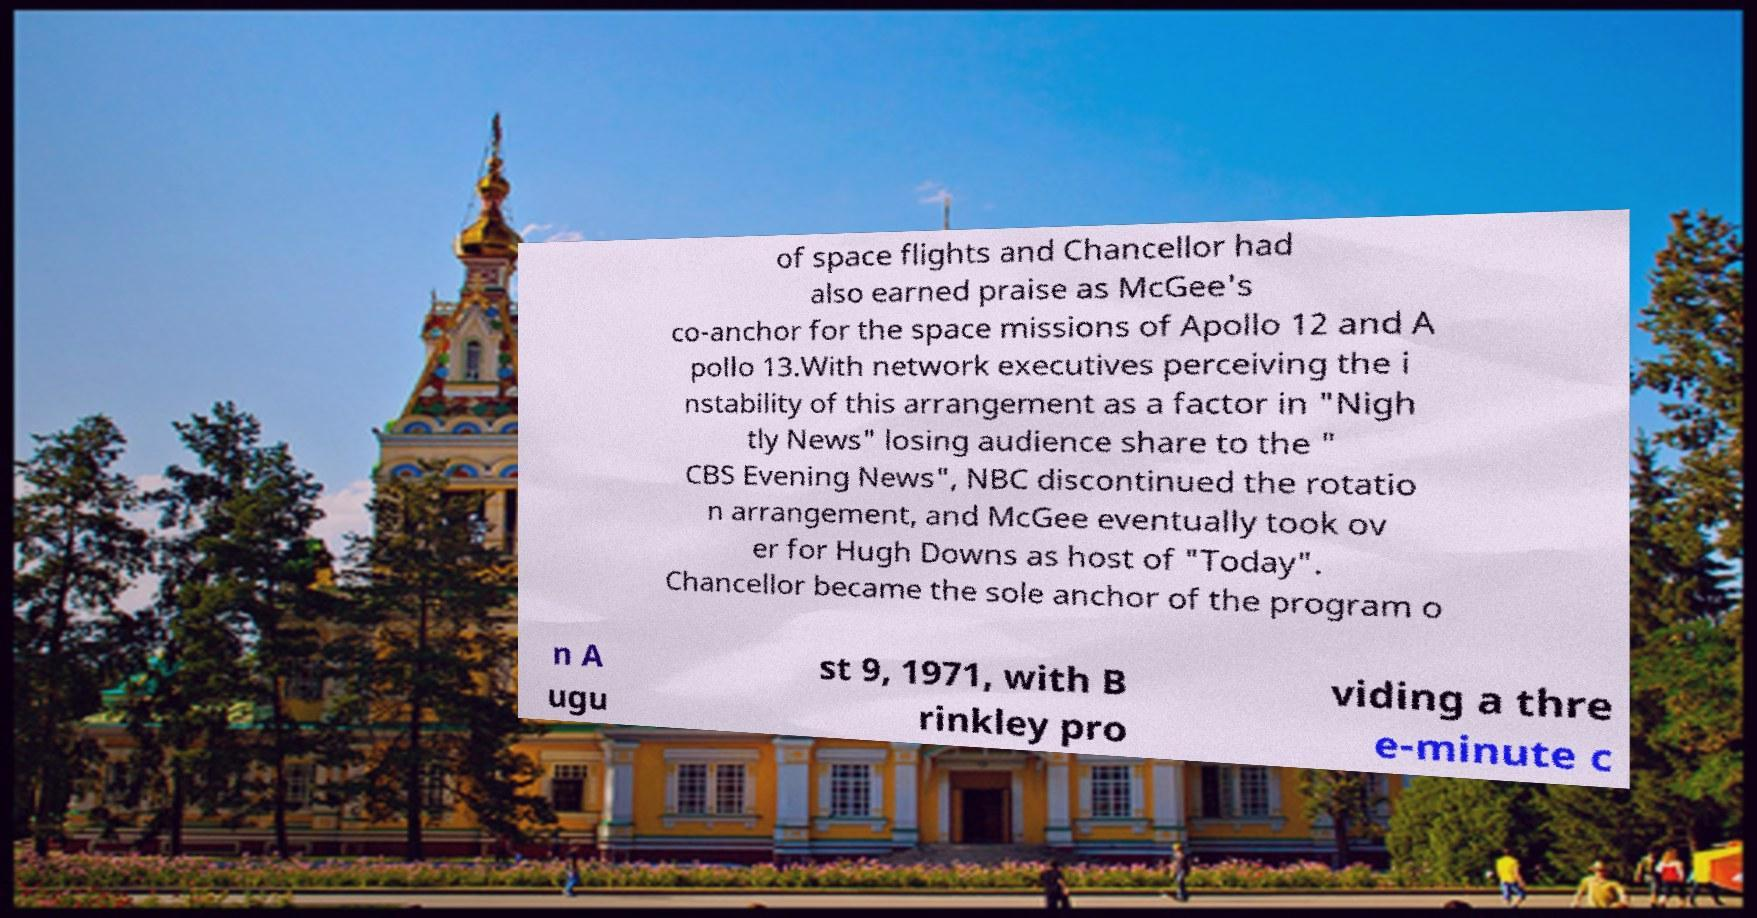Can you accurately transcribe the text from the provided image for me? of space flights and Chancellor had also earned praise as McGee's co-anchor for the space missions of Apollo 12 and A pollo 13.With network executives perceiving the i nstability of this arrangement as a factor in "Nigh tly News" losing audience share to the " CBS Evening News", NBC discontinued the rotatio n arrangement, and McGee eventually took ov er for Hugh Downs as host of "Today". Chancellor became the sole anchor of the program o n A ugu st 9, 1971, with B rinkley pro viding a thre e-minute c 